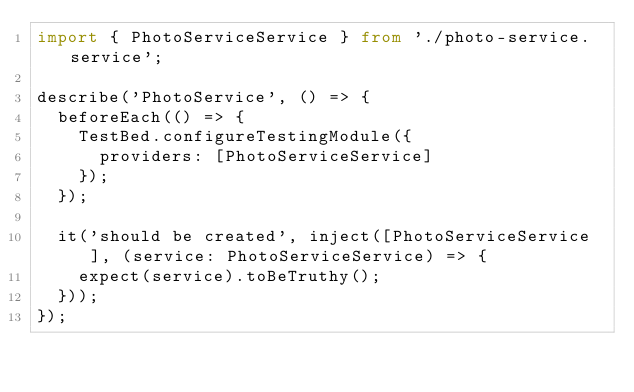Convert code to text. <code><loc_0><loc_0><loc_500><loc_500><_TypeScript_>import { PhotoServiceService } from './photo-service.service';

describe('PhotoService', () => {
  beforeEach(() => {
    TestBed.configureTestingModule({
      providers: [PhotoServiceService]
    });
  });

  it('should be created', inject([PhotoServiceService], (service: PhotoServiceService) => {
    expect(service).toBeTruthy();
  }));
});
</code> 